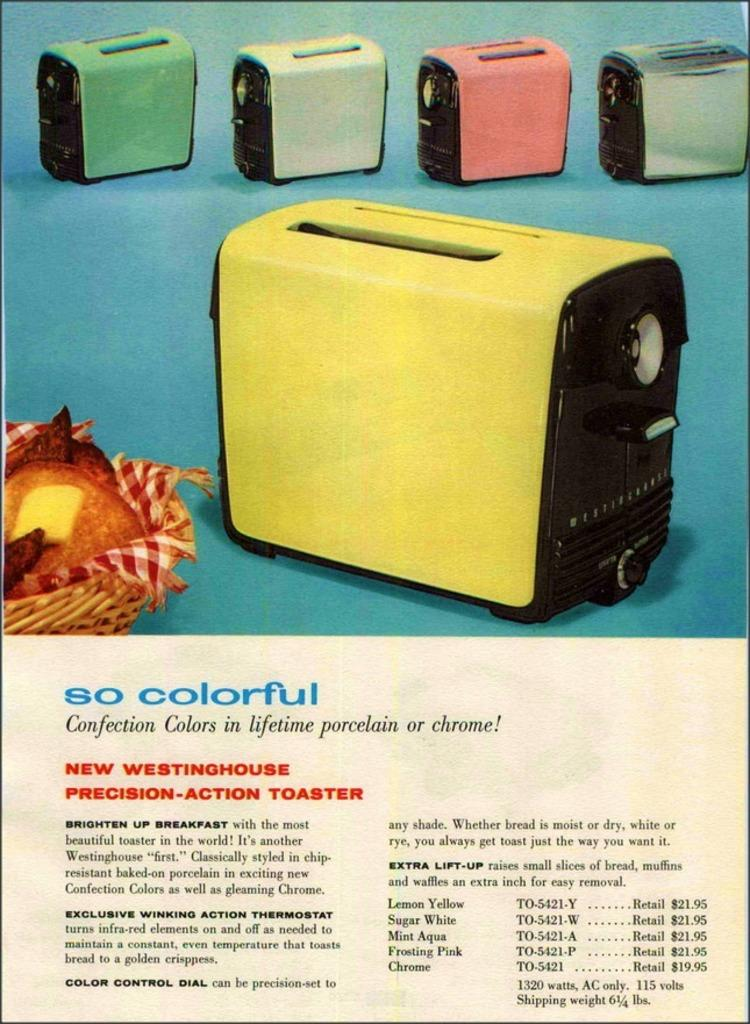What type of appliances are featured in the image? There are colorful toasters in the image. What is the color of the surface on which the toasters are placed? The toasters are on a blue color surface. What else can be seen in the image besides the toasters? There is a cloth and food in a basket in the image. Is there any text present in the image? Yes, there is text written on the image. How does the patch of grass in the image divide the area? There is no patch of grass present in the image; it features colorful toasters, a blue surface, a cloth, a basket with food, and text written on the image. 